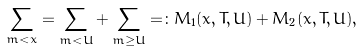<formula> <loc_0><loc_0><loc_500><loc_500>\sum _ { m < x } = \sum _ { m < U } + \sum _ { m \geq U } = \colon M _ { 1 } ( x , T , U ) + M _ { 2 } ( x , T , U ) ,</formula> 